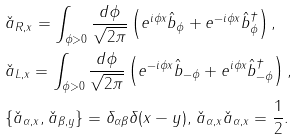Convert formula to latex. <formula><loc_0><loc_0><loc_500><loc_500>& \check { a } _ { R , x } = \int _ { \phi > 0 } \frac { d \phi } { \sqrt { 2 \pi } } \left ( e ^ { i \phi x } \hat { b } _ { \phi } + e ^ { - i \phi x } \hat { b } ^ { \dagger } _ { \phi } \right ) , \\ & \check { a } _ { L , x } = \int _ { \phi > 0 } \frac { d \phi } { \sqrt { 2 \pi } } \left ( e ^ { - i \phi x } \hat { b } _ { - \phi } + e ^ { i \phi x } \hat { b } ^ { \dagger } _ { - \phi } \right ) , \\ & \{ \check { a } _ { \alpha , x } , \check { a } _ { \beta , y } \} = \delta _ { \alpha \beta } \delta ( x - y ) , \, \check { a } _ { \alpha , x } \check { a } _ { \alpha , x } = \frac { 1 } { 2 } .</formula> 